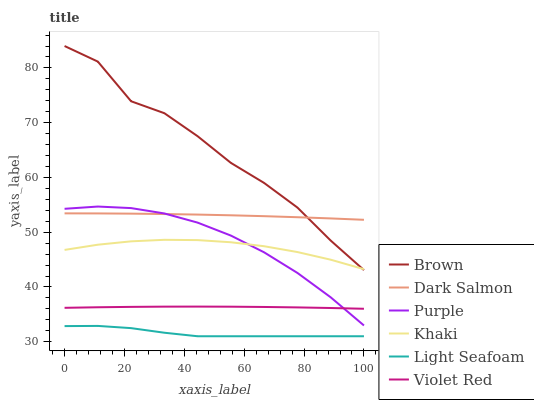Does Light Seafoam have the minimum area under the curve?
Answer yes or no. Yes. Does Brown have the maximum area under the curve?
Answer yes or no. Yes. Does Violet Red have the minimum area under the curve?
Answer yes or no. No. Does Violet Red have the maximum area under the curve?
Answer yes or no. No. Is Dark Salmon the smoothest?
Answer yes or no. Yes. Is Brown the roughest?
Answer yes or no. Yes. Is Violet Red the smoothest?
Answer yes or no. No. Is Violet Red the roughest?
Answer yes or no. No. Does Light Seafoam have the lowest value?
Answer yes or no. Yes. Does Violet Red have the lowest value?
Answer yes or no. No. Does Brown have the highest value?
Answer yes or no. Yes. Does Violet Red have the highest value?
Answer yes or no. No. Is Violet Red less than Brown?
Answer yes or no. Yes. Is Purple greater than Light Seafoam?
Answer yes or no. Yes. Does Purple intersect Dark Salmon?
Answer yes or no. Yes. Is Purple less than Dark Salmon?
Answer yes or no. No. Is Purple greater than Dark Salmon?
Answer yes or no. No. Does Violet Red intersect Brown?
Answer yes or no. No. 